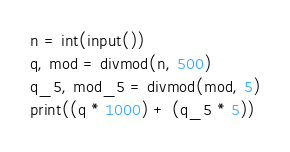Convert code to text. <code><loc_0><loc_0><loc_500><loc_500><_Python_>n = int(input())
q, mod = divmod(n, 500)
q_5, mod_5 = divmod(mod, 5)
print((q * 1000) + (q_5 * 5))</code> 